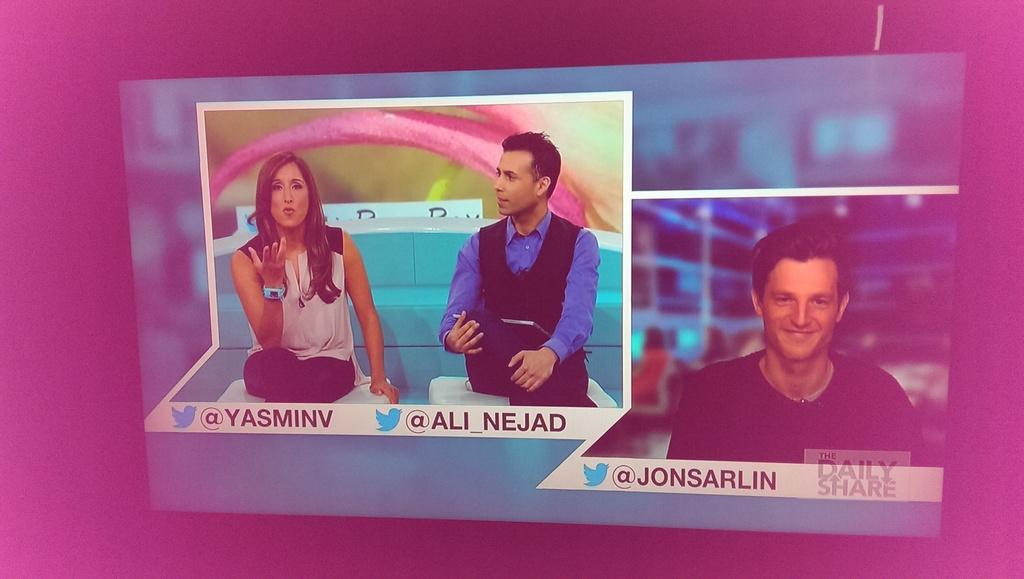What are the people in the image doing? There is a man and a woman sitting on chairs in the image. Can you describe the person on the right side of the image? There is a person on the right side of the image, but we cannot determine their gender or any other details based on the provided facts. What else can be seen in the image besides the people? There is some text visible in the image. What is the rate of the impulse generated by the fifth person in the image? There is no mention of any impulse or fifth person in the image, so this question cannot be answered. 